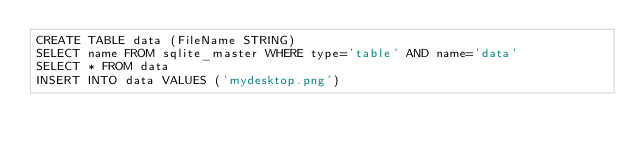<code> <loc_0><loc_0><loc_500><loc_500><_SQL_>CREATE TABLE data (FileName STRING)
SELECT name FROM sqlite_master WHERE type='table' AND name='data'
SELECT * FROM data
INSERT INTO data VALUES ('mydesktop.png')
</code> 